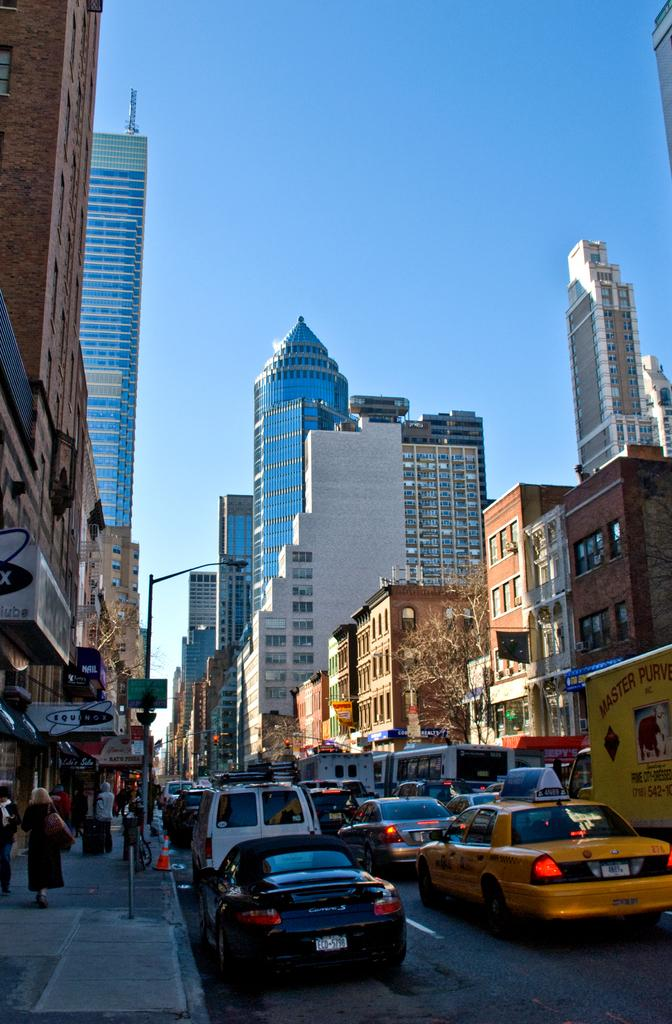What can be seen on the road in the image? There are vehicles on the road in the image. What is located on the left side of the image? There are buildings on the left side of the image. What is located on the right side of the image? There are buildings on the right side of the image. What is visible at the top of the image? The sky is visible at the top of the image. What type of wool is being used by the company in the image? There is no wool or company present in the image. How is the string being used in the image? There is no string present in the image. 